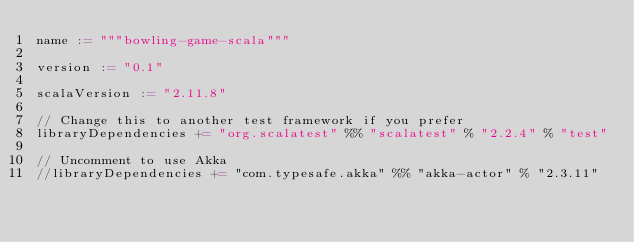Convert code to text. <code><loc_0><loc_0><loc_500><loc_500><_Scala_>name := """bowling-game-scala"""

version := "0.1"

scalaVersion := "2.11.8"

// Change this to another test framework if you prefer
libraryDependencies += "org.scalatest" %% "scalatest" % "2.2.4" % "test"

// Uncomment to use Akka
//libraryDependencies += "com.typesafe.akka" %% "akka-actor" % "2.3.11"

</code> 